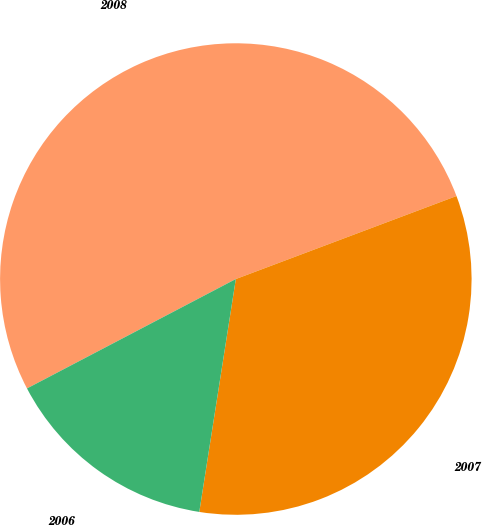<chart> <loc_0><loc_0><loc_500><loc_500><pie_chart><fcel>2008<fcel>2007<fcel>2006<nl><fcel>51.95%<fcel>33.2%<fcel>14.84%<nl></chart> 